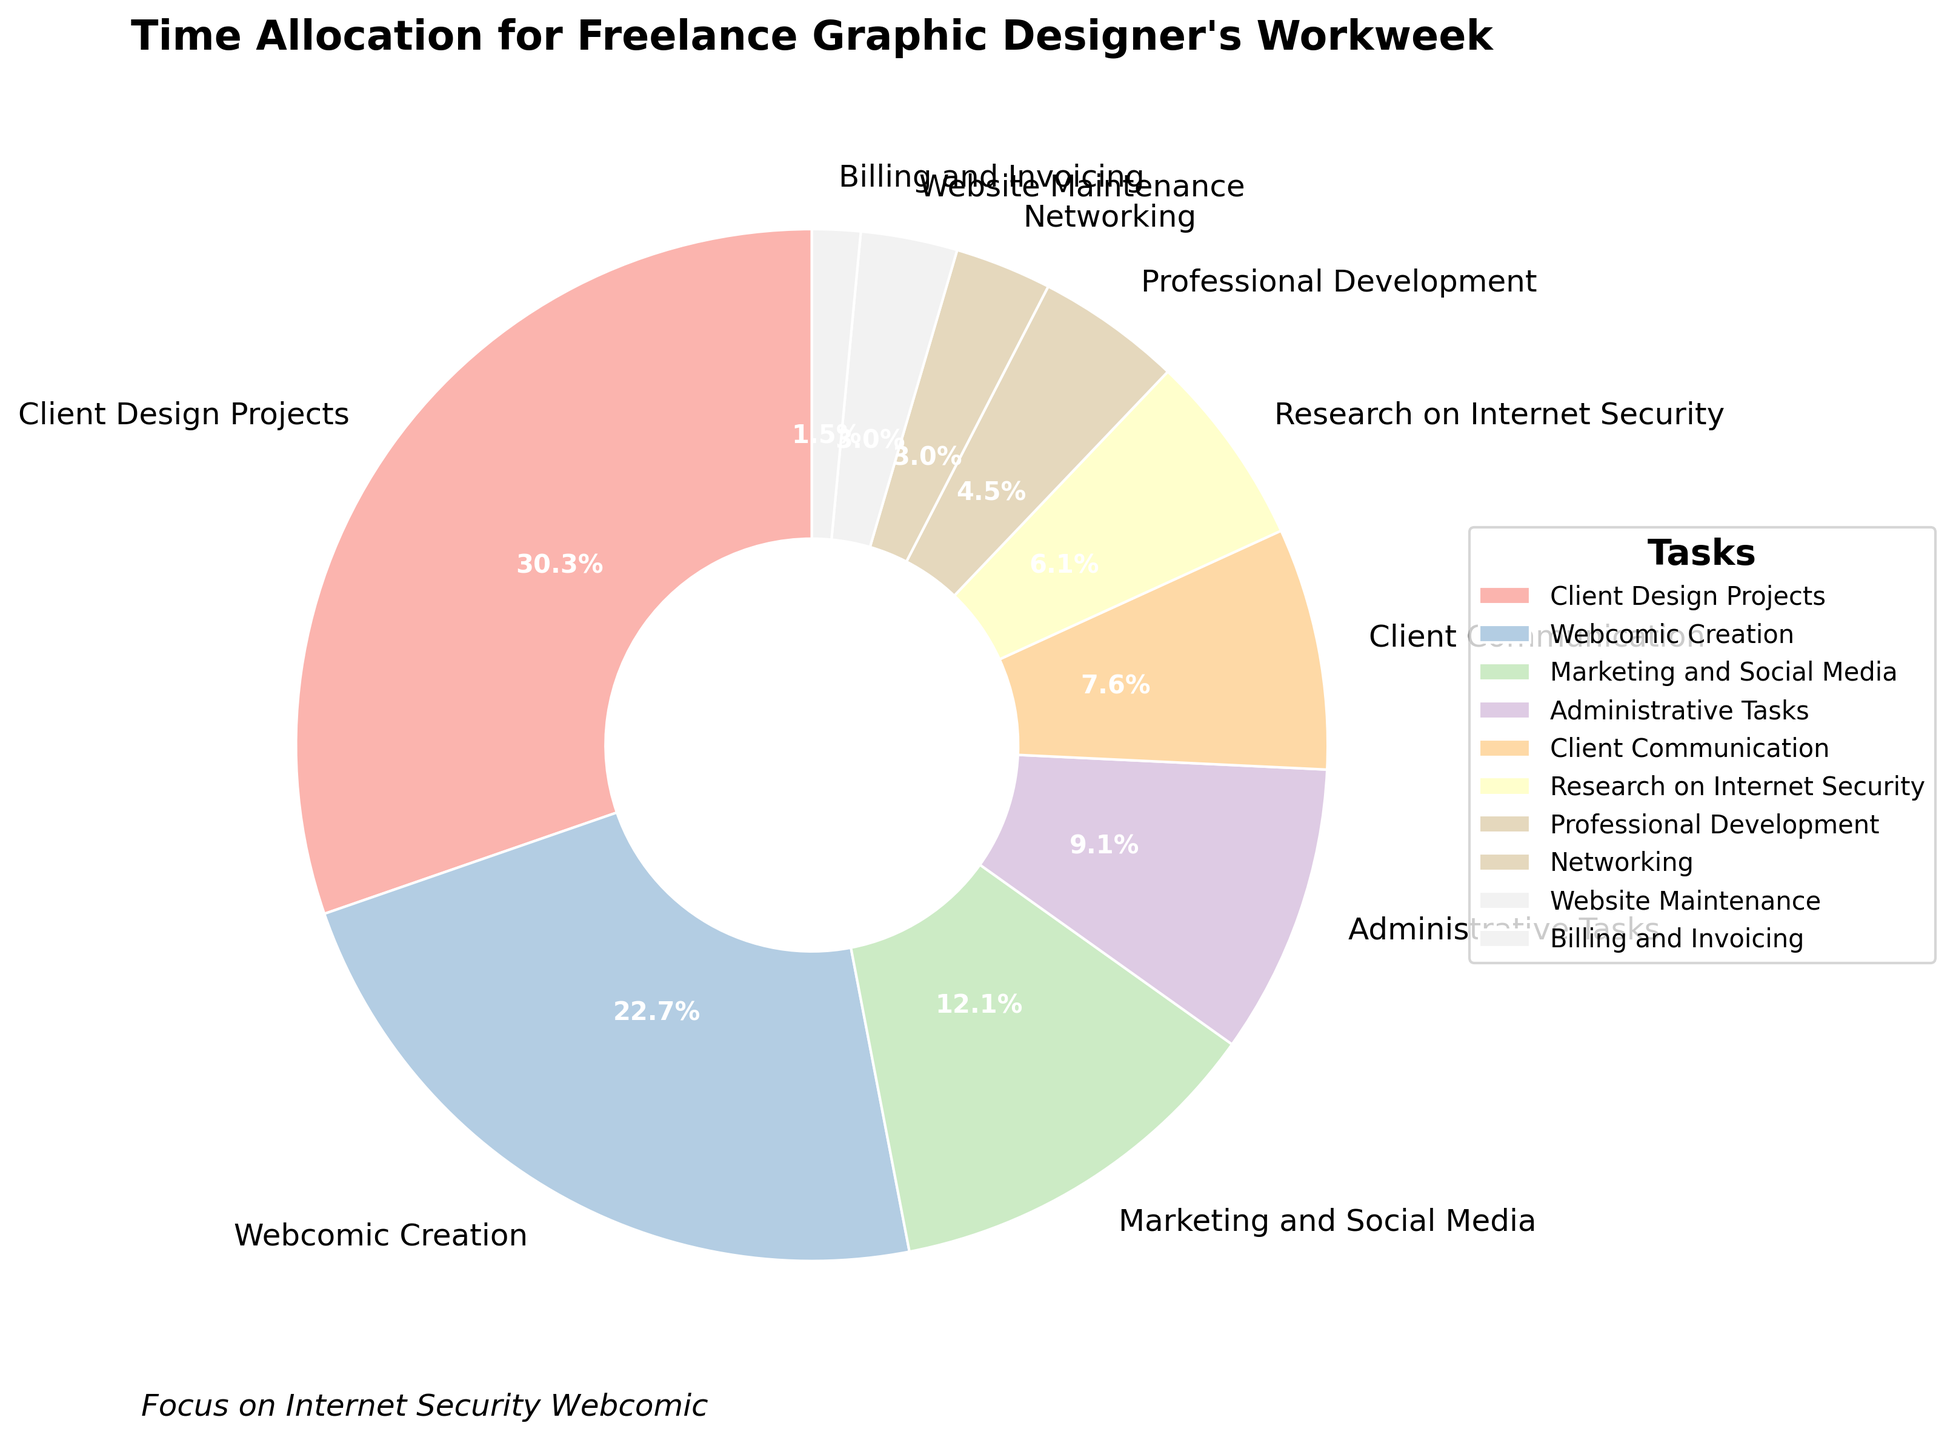What's the percentage of time spent on Webcomic Creation? Locate the section labeled "Webcomic Creation" and refer to the percentage displayed inside the pie wedge.
Answer: 20.8% Which task takes up the most time? Identify the largest pie wedge by comparing the size of each section. Look for the label on this largest wedge.
Answer: Client Design Projects How much more time is spent on Client Design Projects than on Research on Internet Security? Subtract the number of hours for Research on Internet Security (4) from the number of hours for Client Design Projects (20).
Answer: 16 hours What is the combined percentage of time spent on Networking and Website Maintenance? Add the percentages for Networking and Website Maintenance. They are 2.8% and 2.8%, respectively.
Answer: 5.6% How does the time spent on Professional Development compare to that spent on Billing and Invoicing? Look at the pie chart's segments for Professional Development and Billing and Invoicing. Compare their sizes and note the percentages or hours: Professional Development (3 hours) and Billing and Invoicing (1 hour).
Answer: Professional Development is greater What is the median number of hours spent on all tasks? List the hours for all tasks: 1, 2, 2, 3, 4, 5, 6, 8, 15, 20. The median is the middle value when the numbers are sorted in ascending order. With 10 numbers, the median is the average of the 5th and 6th values: (4 + 5)/2.
Answer: 4.5 hours Which tasks are allocated fewer hours than Client Communication? Compare each task's hours to Client Communication's 5 hours. The tasks with fewer hours are: Research on Internet Security (4), Professional Development (3), Networking (2), Website Maintenance (2), and Billing and Invoicing (1).
Answer: Research on Internet Security, Professional Development, Networking, Website Maintenance, Billing and Invoicing If the total number of hours is 66, what percentage of the total workweek is spent on Administrative Tasks? Calculate the percentage by dividing the hours for Administrative Tasks (6) by the total hours (66) and then multiplying by 100. (6/66) * 100 = 9.1%.
Answer: 9.1% What fraction of the workweek is dedicated to Marketing and Social Media? Convert the hours for Marketing and Social Media (8) to a fraction of the total (66). Simplify 8/66, which results in approximately 4/33.
Answer: Approximately 4/33 